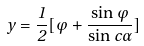Convert formula to latex. <formula><loc_0><loc_0><loc_500><loc_500>y = \frac { 1 } { 2 } [ \varphi + \frac { \sin \varphi } { \sin c \alpha } ]</formula> 